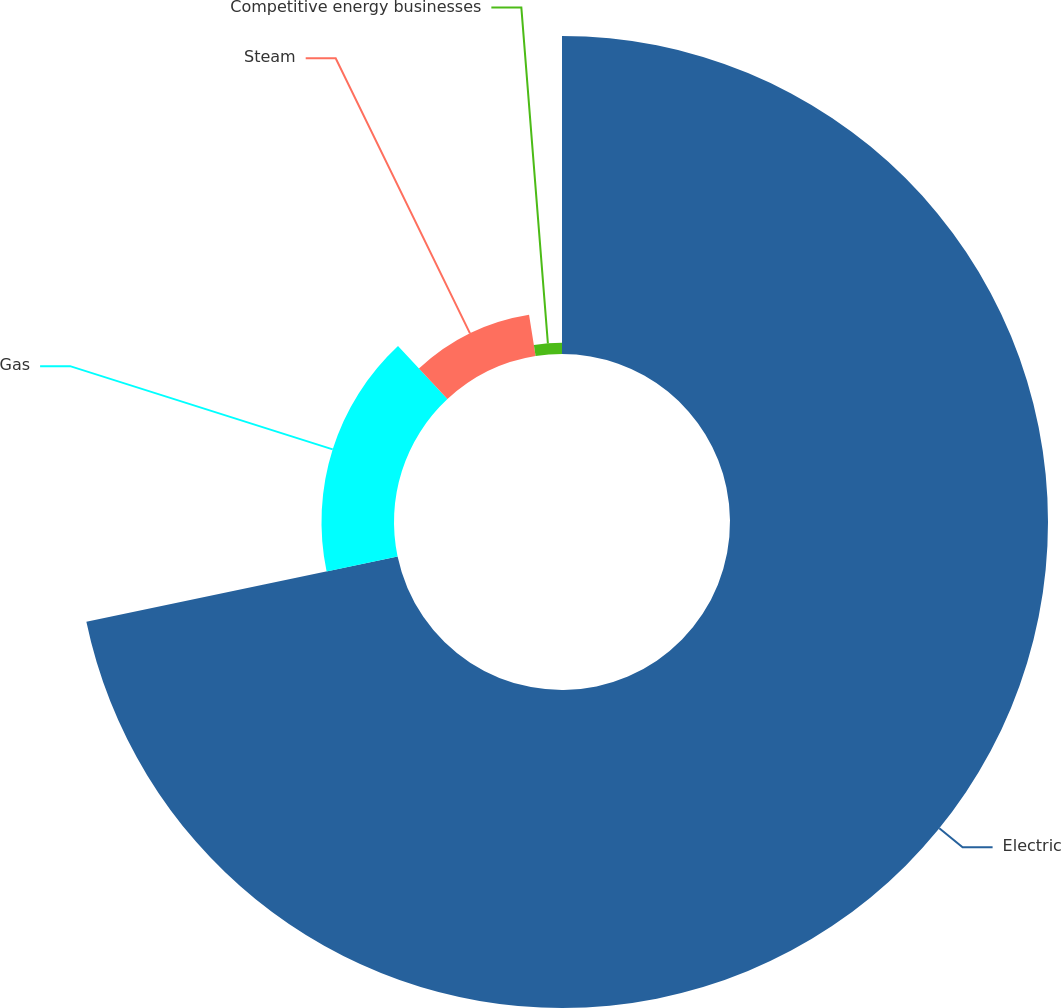<chart> <loc_0><loc_0><loc_500><loc_500><pie_chart><fcel>Electric<fcel>Gas<fcel>Steam<fcel>Competitive energy businesses<nl><fcel>71.7%<fcel>16.35%<fcel>9.43%<fcel>2.51%<nl></chart> 